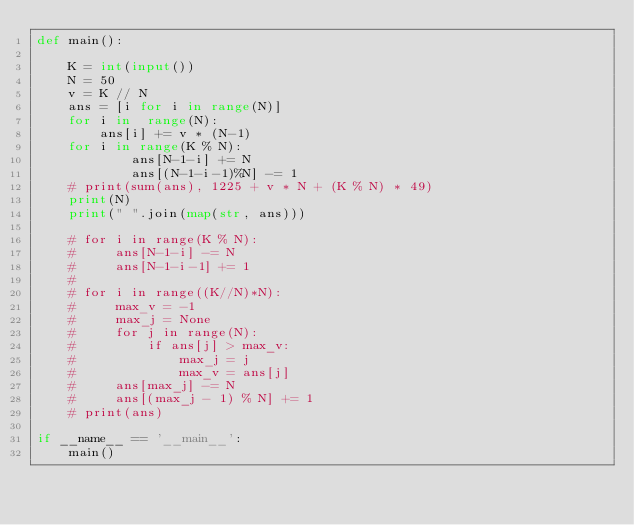Convert code to text. <code><loc_0><loc_0><loc_500><loc_500><_Python_>def main():

    K = int(input())
    N = 50
    v = K // N
    ans = [i for i in range(N)]
    for i in  range(N):
        ans[i] += v * (N-1)
    for i in range(K % N):
            ans[N-1-i] += N
            ans[(N-1-i-1)%N] -= 1
    # print(sum(ans), 1225 + v * N + (K % N) * 49)
    print(N)
    print(" ".join(map(str, ans)))

    # for i in range(K % N):
    #     ans[N-1-i] -= N
    #     ans[N-1-i-1] += 1
    #
    # for i in range((K//N)*N):
    #     max_v = -1
    #     max_j = None
    #     for j in range(N):
    #         if ans[j] > max_v:
    #             max_j = j
    #             max_v = ans[j]
    #     ans[max_j] -= N
    #     ans[(max_j - 1) % N] += 1
    # print(ans)

if __name__ == '__main__':
    main()</code> 